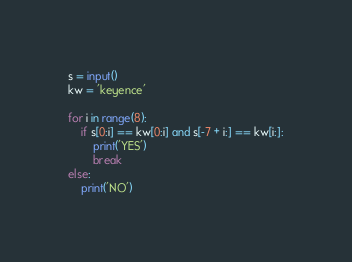Convert code to text. <code><loc_0><loc_0><loc_500><loc_500><_Python_>s = input()
kw = 'keyence'

for i in range(8):
    if s[0:i] == kw[0:i] and s[-7 + i:] == kw[i:]:
        print('YES')
        break
else:
    print('NO')</code> 